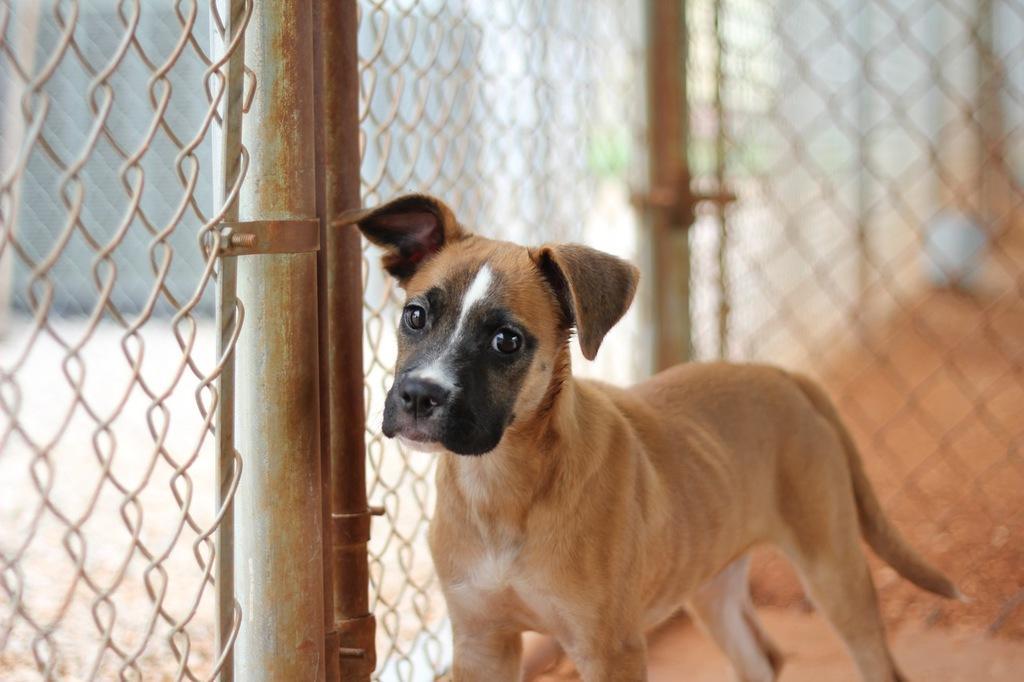Please provide a concise description of this image. In this image there is a dog which is standing beside the fence. On the left side we can see there is a grill, beside the grill there is a pole. 